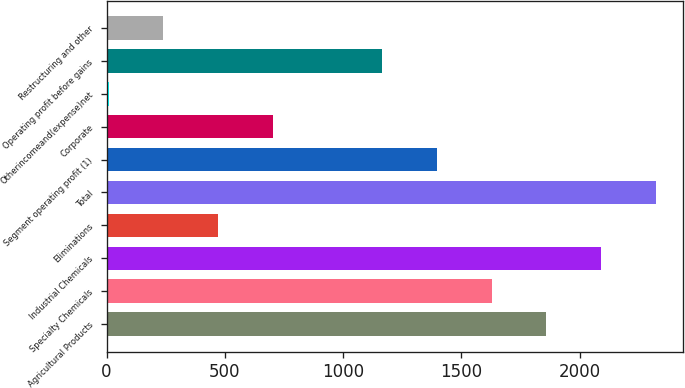<chart> <loc_0><loc_0><loc_500><loc_500><bar_chart><fcel>Agricultural Products<fcel>Specialty Chemicals<fcel>Industrial Chemicals<fcel>Eliminations<fcel>Total<fcel>Segment operating profit (1)<fcel>Corporate<fcel>Otherincomeand(expense)net<fcel>Operating profit before gains<fcel>Restructuring and other<nl><fcel>1858.26<fcel>1627.14<fcel>2089.38<fcel>471.54<fcel>2320.5<fcel>1396.02<fcel>702.66<fcel>9.3<fcel>1164.9<fcel>240.42<nl></chart> 